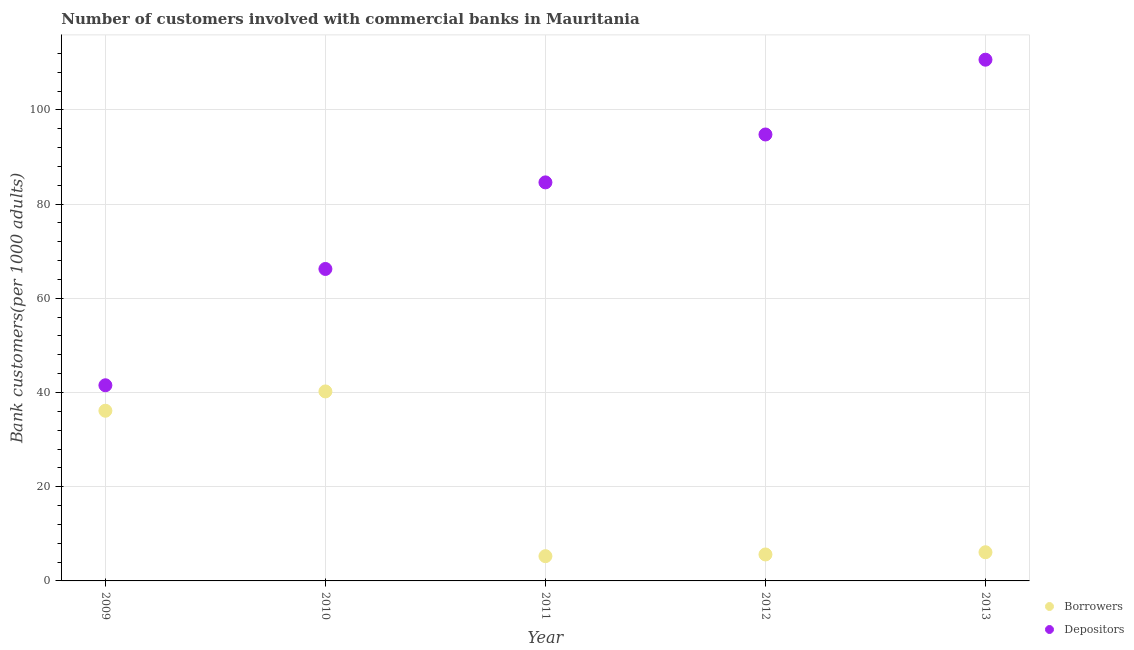How many different coloured dotlines are there?
Offer a terse response. 2. Is the number of dotlines equal to the number of legend labels?
Ensure brevity in your answer.  Yes. What is the number of borrowers in 2009?
Offer a very short reply. 36.13. Across all years, what is the maximum number of depositors?
Keep it short and to the point. 110.66. Across all years, what is the minimum number of borrowers?
Your answer should be compact. 5.26. In which year was the number of borrowers maximum?
Make the answer very short. 2010. In which year was the number of borrowers minimum?
Give a very brief answer. 2011. What is the total number of depositors in the graph?
Give a very brief answer. 397.82. What is the difference between the number of depositors in 2012 and that in 2013?
Provide a succinct answer. -15.88. What is the difference between the number of depositors in 2013 and the number of borrowers in 2012?
Your answer should be very brief. 105.04. What is the average number of depositors per year?
Provide a succinct answer. 79.56. In the year 2009, what is the difference between the number of depositors and number of borrowers?
Provide a succinct answer. 5.41. In how many years, is the number of depositors greater than 52?
Keep it short and to the point. 4. What is the ratio of the number of depositors in 2009 to that in 2011?
Offer a very short reply. 0.49. Is the difference between the number of borrowers in 2010 and 2012 greater than the difference between the number of depositors in 2010 and 2012?
Provide a succinct answer. Yes. What is the difference between the highest and the second highest number of depositors?
Ensure brevity in your answer.  15.88. What is the difference between the highest and the lowest number of depositors?
Provide a succinct answer. 69.12. Is the number of depositors strictly less than the number of borrowers over the years?
Your answer should be compact. No. How many years are there in the graph?
Make the answer very short. 5. Does the graph contain any zero values?
Offer a very short reply. No. How many legend labels are there?
Give a very brief answer. 2. How are the legend labels stacked?
Ensure brevity in your answer.  Vertical. What is the title of the graph?
Offer a very short reply. Number of customers involved with commercial banks in Mauritania. What is the label or title of the X-axis?
Provide a short and direct response. Year. What is the label or title of the Y-axis?
Provide a succinct answer. Bank customers(per 1000 adults). What is the Bank customers(per 1000 adults) in Borrowers in 2009?
Your response must be concise. 36.13. What is the Bank customers(per 1000 adults) in Depositors in 2009?
Ensure brevity in your answer.  41.54. What is the Bank customers(per 1000 adults) of Borrowers in 2010?
Provide a succinct answer. 40.23. What is the Bank customers(per 1000 adults) of Depositors in 2010?
Provide a short and direct response. 66.23. What is the Bank customers(per 1000 adults) of Borrowers in 2011?
Provide a succinct answer. 5.26. What is the Bank customers(per 1000 adults) of Depositors in 2011?
Your answer should be compact. 84.61. What is the Bank customers(per 1000 adults) in Borrowers in 2012?
Offer a terse response. 5.62. What is the Bank customers(per 1000 adults) of Depositors in 2012?
Your answer should be compact. 94.78. What is the Bank customers(per 1000 adults) in Borrowers in 2013?
Provide a short and direct response. 6.09. What is the Bank customers(per 1000 adults) in Depositors in 2013?
Offer a terse response. 110.66. Across all years, what is the maximum Bank customers(per 1000 adults) in Borrowers?
Your answer should be very brief. 40.23. Across all years, what is the maximum Bank customers(per 1000 adults) of Depositors?
Ensure brevity in your answer.  110.66. Across all years, what is the minimum Bank customers(per 1000 adults) in Borrowers?
Make the answer very short. 5.26. Across all years, what is the minimum Bank customers(per 1000 adults) in Depositors?
Your response must be concise. 41.54. What is the total Bank customers(per 1000 adults) in Borrowers in the graph?
Give a very brief answer. 93.32. What is the total Bank customers(per 1000 adults) in Depositors in the graph?
Offer a very short reply. 397.82. What is the difference between the Bank customers(per 1000 adults) of Borrowers in 2009 and that in 2010?
Keep it short and to the point. -4.1. What is the difference between the Bank customers(per 1000 adults) in Depositors in 2009 and that in 2010?
Give a very brief answer. -24.69. What is the difference between the Bank customers(per 1000 adults) in Borrowers in 2009 and that in 2011?
Give a very brief answer. 30.88. What is the difference between the Bank customers(per 1000 adults) in Depositors in 2009 and that in 2011?
Provide a succinct answer. -43.07. What is the difference between the Bank customers(per 1000 adults) in Borrowers in 2009 and that in 2012?
Your answer should be very brief. 30.51. What is the difference between the Bank customers(per 1000 adults) of Depositors in 2009 and that in 2012?
Keep it short and to the point. -53.24. What is the difference between the Bank customers(per 1000 adults) in Borrowers in 2009 and that in 2013?
Give a very brief answer. 30.04. What is the difference between the Bank customers(per 1000 adults) in Depositors in 2009 and that in 2013?
Give a very brief answer. -69.12. What is the difference between the Bank customers(per 1000 adults) in Borrowers in 2010 and that in 2011?
Ensure brevity in your answer.  34.97. What is the difference between the Bank customers(per 1000 adults) of Depositors in 2010 and that in 2011?
Give a very brief answer. -18.38. What is the difference between the Bank customers(per 1000 adults) in Borrowers in 2010 and that in 2012?
Your answer should be compact. 34.61. What is the difference between the Bank customers(per 1000 adults) of Depositors in 2010 and that in 2012?
Ensure brevity in your answer.  -28.55. What is the difference between the Bank customers(per 1000 adults) in Borrowers in 2010 and that in 2013?
Your answer should be very brief. 34.14. What is the difference between the Bank customers(per 1000 adults) of Depositors in 2010 and that in 2013?
Make the answer very short. -44.43. What is the difference between the Bank customers(per 1000 adults) of Borrowers in 2011 and that in 2012?
Give a very brief answer. -0.36. What is the difference between the Bank customers(per 1000 adults) in Depositors in 2011 and that in 2012?
Provide a short and direct response. -10.17. What is the difference between the Bank customers(per 1000 adults) in Borrowers in 2011 and that in 2013?
Your answer should be compact. -0.83. What is the difference between the Bank customers(per 1000 adults) of Depositors in 2011 and that in 2013?
Make the answer very short. -26.05. What is the difference between the Bank customers(per 1000 adults) in Borrowers in 2012 and that in 2013?
Offer a very short reply. -0.47. What is the difference between the Bank customers(per 1000 adults) in Depositors in 2012 and that in 2013?
Your answer should be very brief. -15.88. What is the difference between the Bank customers(per 1000 adults) in Borrowers in 2009 and the Bank customers(per 1000 adults) in Depositors in 2010?
Your answer should be compact. -30.1. What is the difference between the Bank customers(per 1000 adults) of Borrowers in 2009 and the Bank customers(per 1000 adults) of Depositors in 2011?
Provide a succinct answer. -48.48. What is the difference between the Bank customers(per 1000 adults) of Borrowers in 2009 and the Bank customers(per 1000 adults) of Depositors in 2012?
Keep it short and to the point. -58.65. What is the difference between the Bank customers(per 1000 adults) in Borrowers in 2009 and the Bank customers(per 1000 adults) in Depositors in 2013?
Offer a very short reply. -74.53. What is the difference between the Bank customers(per 1000 adults) of Borrowers in 2010 and the Bank customers(per 1000 adults) of Depositors in 2011?
Provide a short and direct response. -44.38. What is the difference between the Bank customers(per 1000 adults) of Borrowers in 2010 and the Bank customers(per 1000 adults) of Depositors in 2012?
Your response must be concise. -54.55. What is the difference between the Bank customers(per 1000 adults) of Borrowers in 2010 and the Bank customers(per 1000 adults) of Depositors in 2013?
Keep it short and to the point. -70.43. What is the difference between the Bank customers(per 1000 adults) in Borrowers in 2011 and the Bank customers(per 1000 adults) in Depositors in 2012?
Ensure brevity in your answer.  -89.52. What is the difference between the Bank customers(per 1000 adults) in Borrowers in 2011 and the Bank customers(per 1000 adults) in Depositors in 2013?
Offer a terse response. -105.4. What is the difference between the Bank customers(per 1000 adults) of Borrowers in 2012 and the Bank customers(per 1000 adults) of Depositors in 2013?
Your answer should be very brief. -105.04. What is the average Bank customers(per 1000 adults) in Borrowers per year?
Keep it short and to the point. 18.66. What is the average Bank customers(per 1000 adults) in Depositors per year?
Offer a terse response. 79.56. In the year 2009, what is the difference between the Bank customers(per 1000 adults) of Borrowers and Bank customers(per 1000 adults) of Depositors?
Offer a very short reply. -5.41. In the year 2010, what is the difference between the Bank customers(per 1000 adults) in Borrowers and Bank customers(per 1000 adults) in Depositors?
Make the answer very short. -26. In the year 2011, what is the difference between the Bank customers(per 1000 adults) in Borrowers and Bank customers(per 1000 adults) in Depositors?
Your answer should be compact. -79.36. In the year 2012, what is the difference between the Bank customers(per 1000 adults) of Borrowers and Bank customers(per 1000 adults) of Depositors?
Offer a terse response. -89.16. In the year 2013, what is the difference between the Bank customers(per 1000 adults) in Borrowers and Bank customers(per 1000 adults) in Depositors?
Give a very brief answer. -104.57. What is the ratio of the Bank customers(per 1000 adults) of Borrowers in 2009 to that in 2010?
Keep it short and to the point. 0.9. What is the ratio of the Bank customers(per 1000 adults) of Depositors in 2009 to that in 2010?
Make the answer very short. 0.63. What is the ratio of the Bank customers(per 1000 adults) of Borrowers in 2009 to that in 2011?
Offer a terse response. 6.87. What is the ratio of the Bank customers(per 1000 adults) in Depositors in 2009 to that in 2011?
Provide a short and direct response. 0.49. What is the ratio of the Bank customers(per 1000 adults) in Borrowers in 2009 to that in 2012?
Offer a very short reply. 6.43. What is the ratio of the Bank customers(per 1000 adults) in Depositors in 2009 to that in 2012?
Ensure brevity in your answer.  0.44. What is the ratio of the Bank customers(per 1000 adults) of Borrowers in 2009 to that in 2013?
Provide a succinct answer. 5.93. What is the ratio of the Bank customers(per 1000 adults) in Depositors in 2009 to that in 2013?
Ensure brevity in your answer.  0.38. What is the ratio of the Bank customers(per 1000 adults) in Borrowers in 2010 to that in 2011?
Provide a succinct answer. 7.65. What is the ratio of the Bank customers(per 1000 adults) of Depositors in 2010 to that in 2011?
Offer a terse response. 0.78. What is the ratio of the Bank customers(per 1000 adults) of Borrowers in 2010 to that in 2012?
Give a very brief answer. 7.16. What is the ratio of the Bank customers(per 1000 adults) in Depositors in 2010 to that in 2012?
Keep it short and to the point. 0.7. What is the ratio of the Bank customers(per 1000 adults) in Borrowers in 2010 to that in 2013?
Give a very brief answer. 6.61. What is the ratio of the Bank customers(per 1000 adults) of Depositors in 2010 to that in 2013?
Ensure brevity in your answer.  0.6. What is the ratio of the Bank customers(per 1000 adults) in Borrowers in 2011 to that in 2012?
Give a very brief answer. 0.94. What is the ratio of the Bank customers(per 1000 adults) in Depositors in 2011 to that in 2012?
Offer a terse response. 0.89. What is the ratio of the Bank customers(per 1000 adults) in Borrowers in 2011 to that in 2013?
Your answer should be compact. 0.86. What is the ratio of the Bank customers(per 1000 adults) of Depositors in 2011 to that in 2013?
Give a very brief answer. 0.76. What is the ratio of the Bank customers(per 1000 adults) of Borrowers in 2012 to that in 2013?
Provide a succinct answer. 0.92. What is the ratio of the Bank customers(per 1000 adults) in Depositors in 2012 to that in 2013?
Give a very brief answer. 0.86. What is the difference between the highest and the second highest Bank customers(per 1000 adults) in Borrowers?
Provide a short and direct response. 4.1. What is the difference between the highest and the second highest Bank customers(per 1000 adults) of Depositors?
Give a very brief answer. 15.88. What is the difference between the highest and the lowest Bank customers(per 1000 adults) in Borrowers?
Your answer should be very brief. 34.97. What is the difference between the highest and the lowest Bank customers(per 1000 adults) in Depositors?
Your answer should be compact. 69.12. 